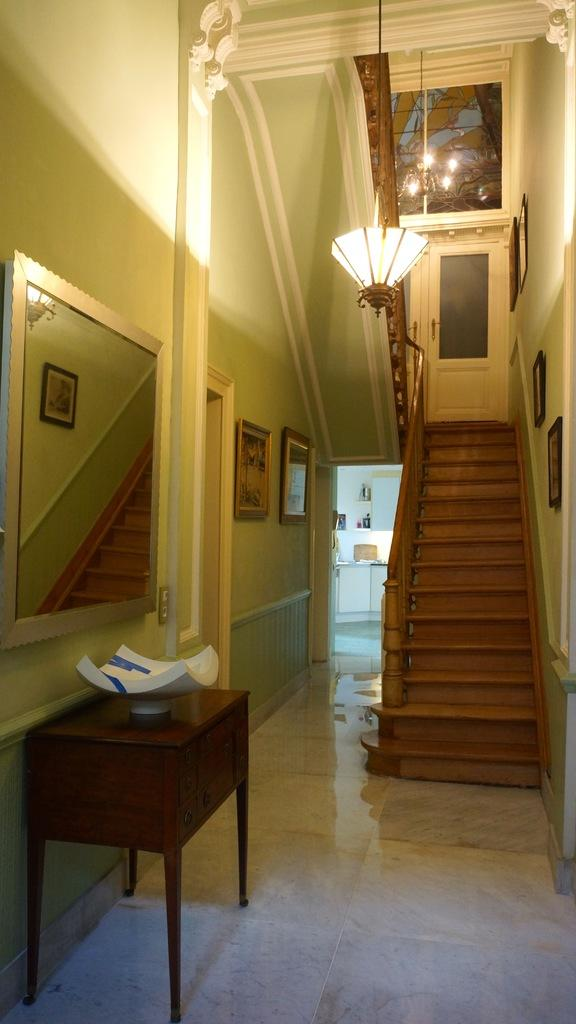What is located in the foreground of the image? There is a table in the foreground of the image. What architectural feature can be seen in the image? There is a staircase in the image. What type of decoration is present on the wall in the image? There is a wall with wall paintings in the image. What object might be used for personal grooming in the image? There is a mirror in the image. What type of lighting fixture is present in the image? A chandelier is hanged at the top of the image. Where was the image taken? The image was taken in a house. What type of book is being read by the character in the image? There is no character or book present in the image; it features a table, staircase, wall paintings, mirror, chandelier, and a house setting. 